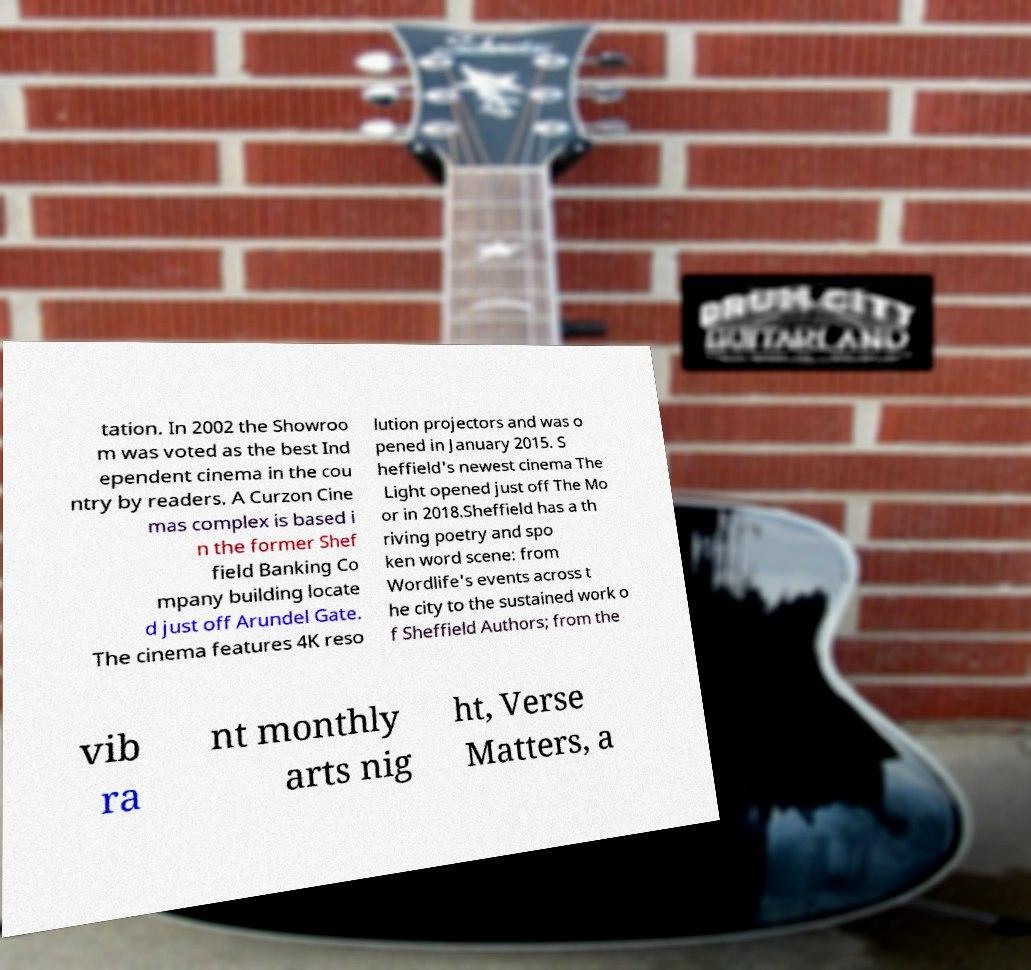What messages or text are displayed in this image? I need them in a readable, typed format. tation. In 2002 the Showroo m was voted as the best Ind ependent cinema in the cou ntry by readers. A Curzon Cine mas complex is based i n the former Shef field Banking Co mpany building locate d just off Arundel Gate. The cinema features 4K reso lution projectors and was o pened in January 2015. S heffield's newest cinema The Light opened just off The Mo or in 2018.Sheffield has a th riving poetry and spo ken word scene: from Wordlife's events across t he city to the sustained work o f Sheffield Authors; from the vib ra nt monthly arts nig ht, Verse Matters, a 